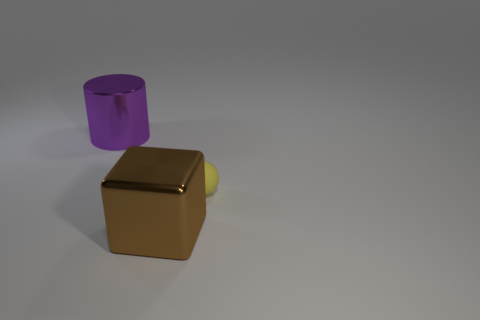Do the large thing that is to the left of the big brown thing and the brown block have the same material? While both objects display a reflective surface, upon closer examination, the object to the left seems to have a slightly different sheen, indicating a variance in material finish that can affect the perception of whether they are the same material or not. It is also important to consider that two objects can be made of the same base material, such as plastic or metal, but surface treatments can give them different textures and appearances. 